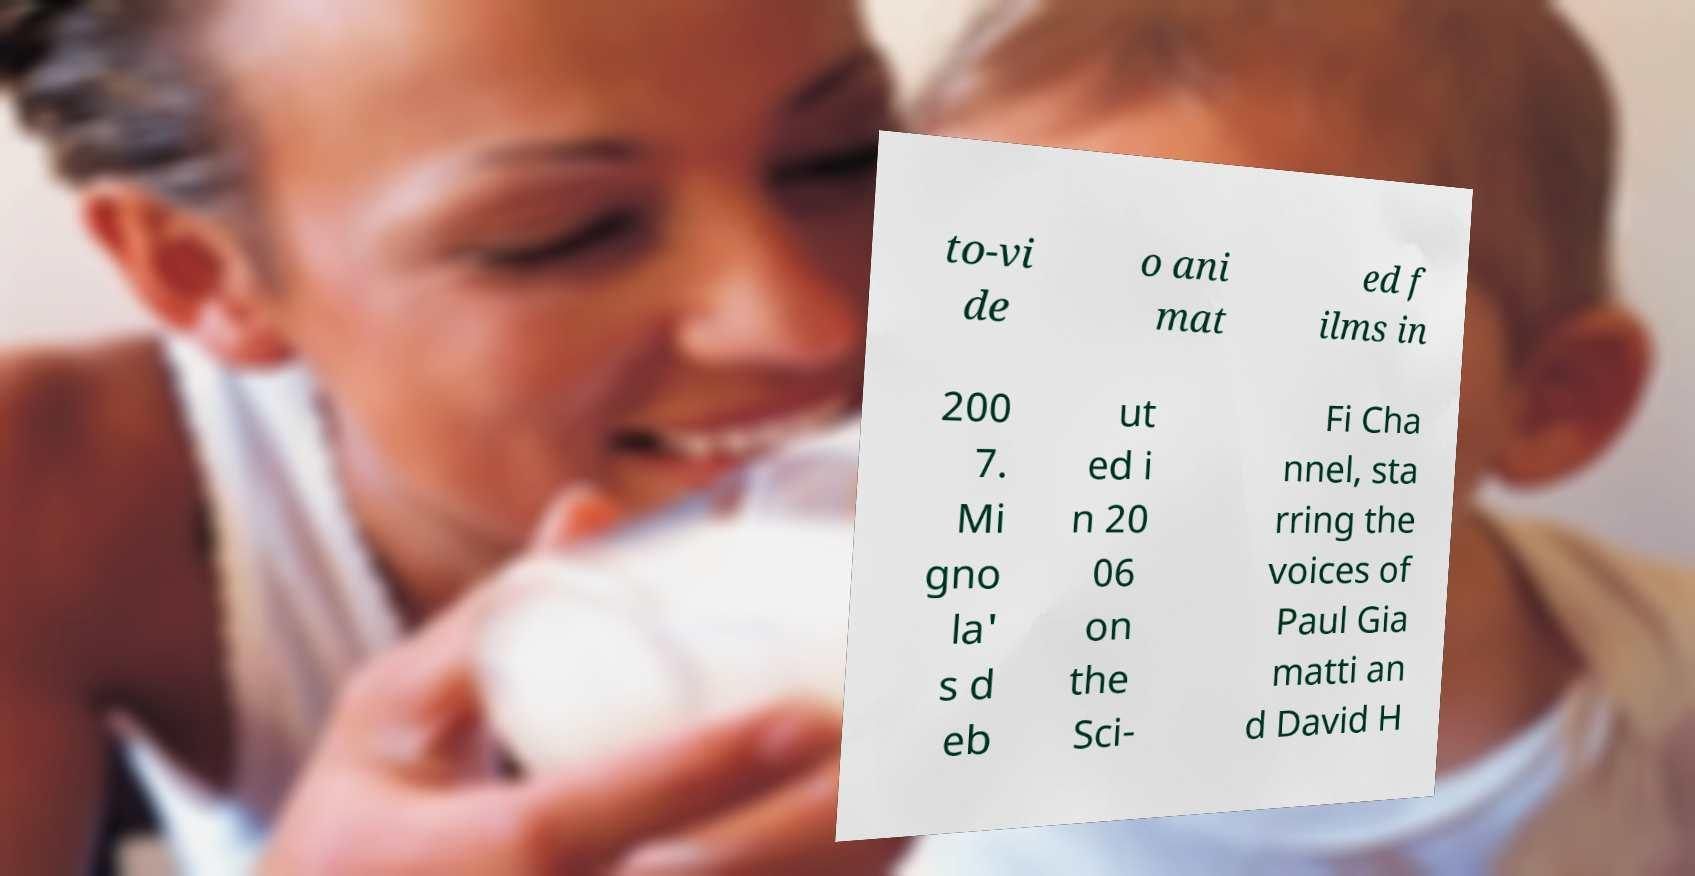What messages or text are displayed in this image? I need them in a readable, typed format. to-vi de o ani mat ed f ilms in 200 7. Mi gno la' s d eb ut ed i n 20 06 on the Sci- Fi Cha nnel, sta rring the voices of Paul Gia matti an d David H 